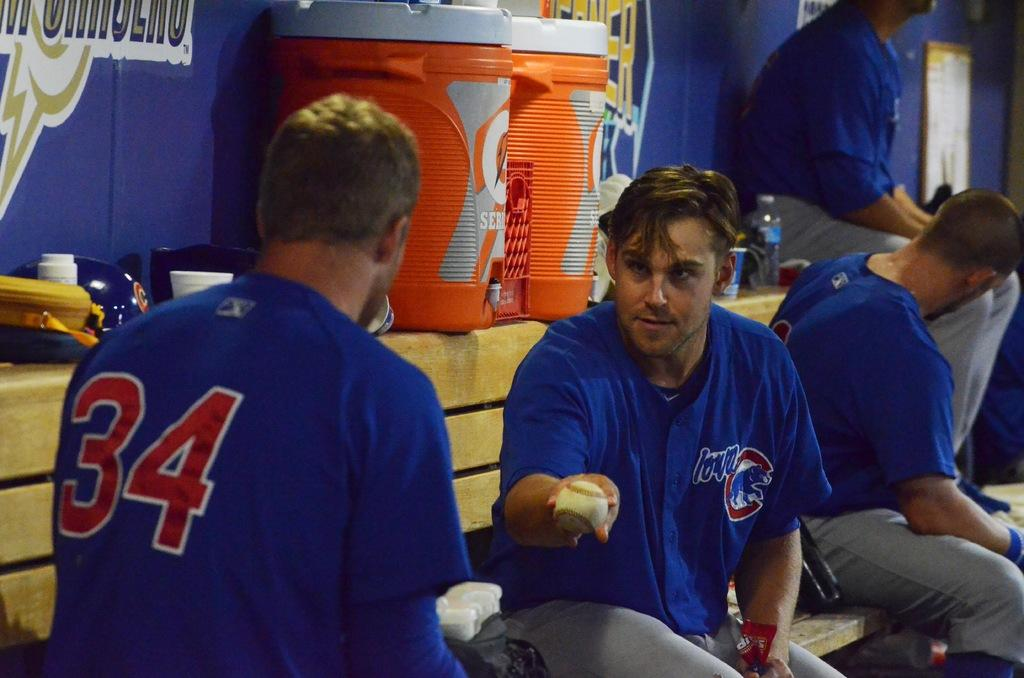<image>
Relay a brief, clear account of the picture shown. A baseball player lovingly offer his ball to player number 34 